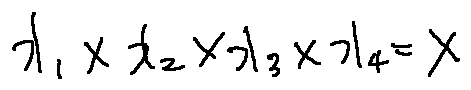<formula> <loc_0><loc_0><loc_500><loc_500>x _ { 1 } \times x _ { 2 } \times x _ { 3 } \times x _ { 4 } = X</formula> 